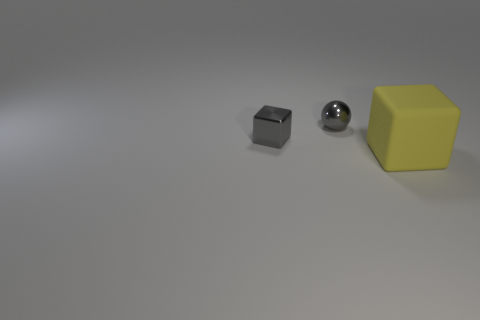There is a metallic cube that is the same size as the metal sphere; what color is it? The metallic cube in the image appears to be gray, exhibiting a lustrous finish characteristic of metallic surfaces, which might suggest it is made of a material such as steel or aluminum. 